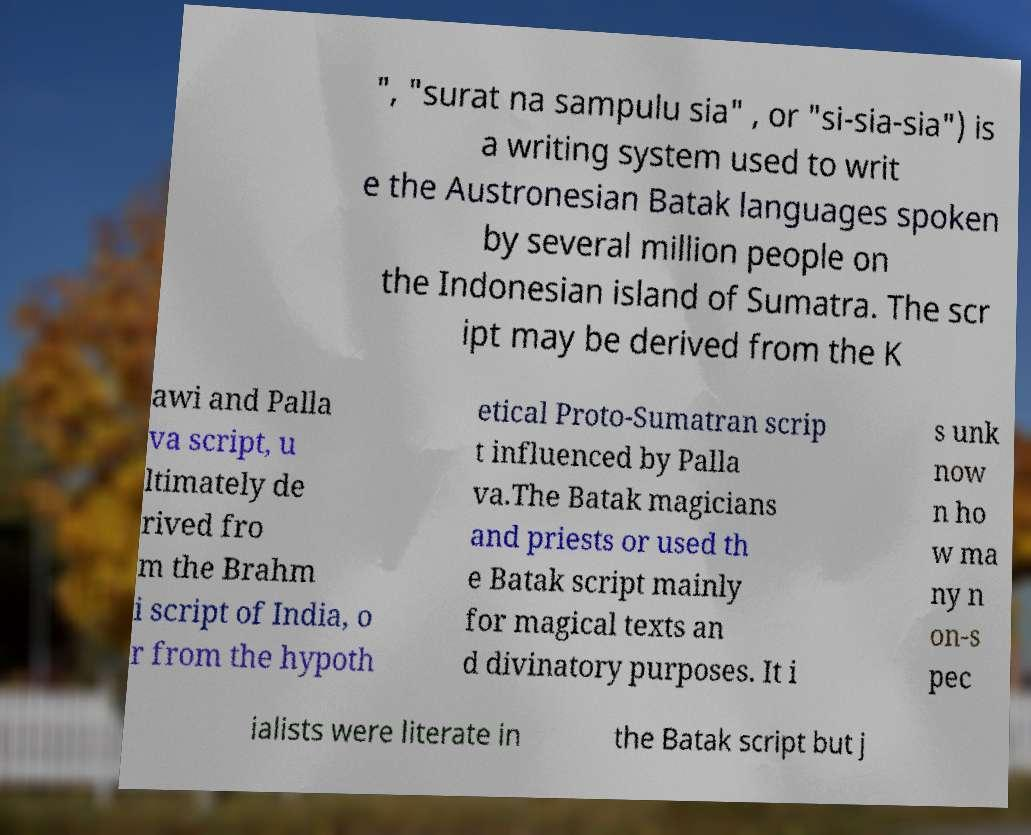Could you extract and type out the text from this image? ", "surat na sampulu sia" , or "si-sia-sia") is a writing system used to writ e the Austronesian Batak languages spoken by several million people on the Indonesian island of Sumatra. The scr ipt may be derived from the K awi and Palla va script, u ltimately de rived fro m the Brahm i script of India, o r from the hypoth etical Proto-Sumatran scrip t influenced by Palla va.The Batak magicians and priests or used th e Batak script mainly for magical texts an d divinatory purposes. It i s unk now n ho w ma ny n on-s pec ialists were literate in the Batak script but j 